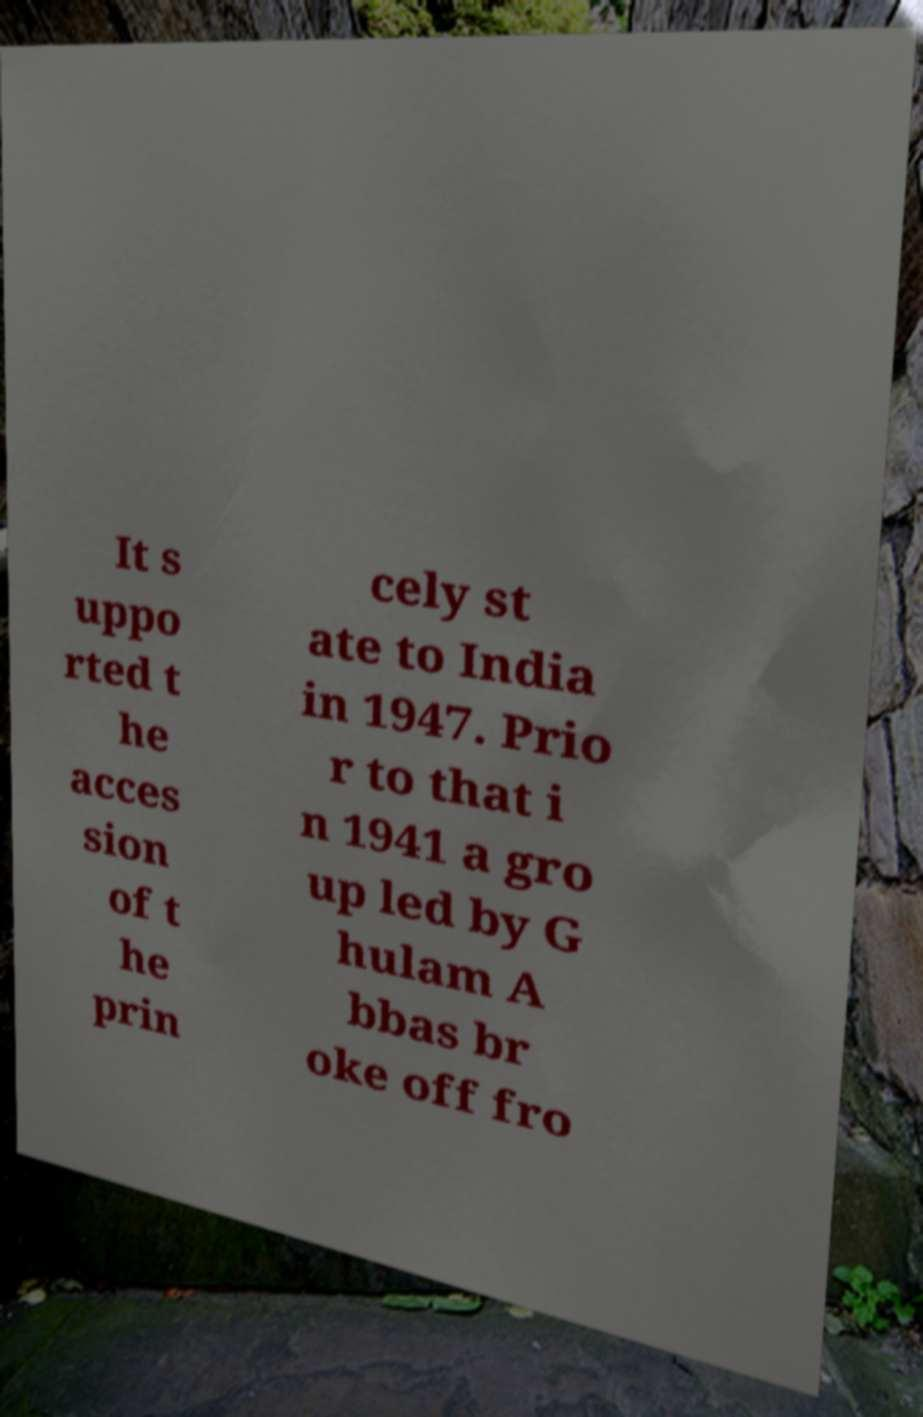I need the written content from this picture converted into text. Can you do that? It s uppo rted t he acces sion of t he prin cely st ate to India in 1947. Prio r to that i n 1941 a gro up led by G hulam A bbas br oke off fro 